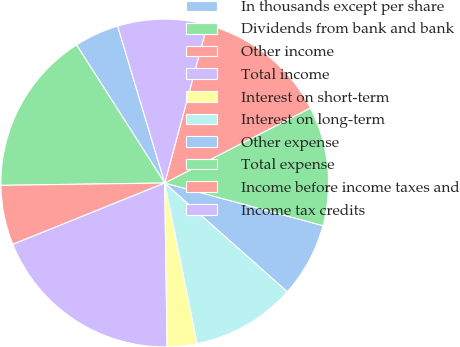Convert chart to OTSL. <chart><loc_0><loc_0><loc_500><loc_500><pie_chart><fcel>In thousands except per share<fcel>Dividends from bank and bank<fcel>Other income<fcel>Total income<fcel>Interest on short-term<fcel>Interest on long-term<fcel>Other expense<fcel>Total expense<fcel>Income before income taxes and<fcel>Income tax credits<nl><fcel>4.41%<fcel>16.18%<fcel>5.88%<fcel>19.12%<fcel>2.94%<fcel>10.29%<fcel>7.35%<fcel>11.76%<fcel>13.24%<fcel>8.82%<nl></chart> 